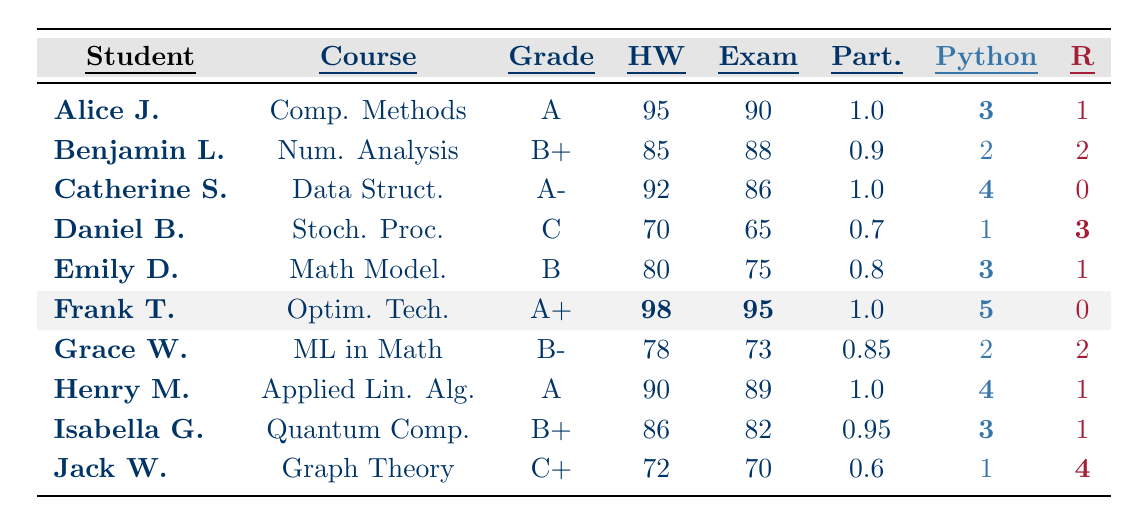What is the final grade of Henry Martinez? By looking at the table, I find the row corresponding to Henry Martinez, and the final grade listed under the "Grade" column is "A."
Answer: A How many homework points did Frank Thompson earn? In the row for Frank Thompson, the homework score located in the "HW" column shows 98 points.
Answer: 98 Which student had the highest exam score? I check the "Exam" column for each student and see that Frank Thompson has the highest score of 95.
Answer: Frank Thompson What is the average Participation score of all students? I sum up the participation scores (1.0 + 0.9 + 1.0 + 0.7 + 0.8 + 1.0 + 0.85 + 1.0 + 0.95 + 0.6) = 9.1 and divide by 10 (the number of students), resulting in an average of 0.91.
Answer: 0.91 Does any student have a higher number of Python projects than R projects? I examine each student's Python and R project counts and find that students such as Alice Johnson and Catherine Smith have more Python projects (3 and 4, respectively) compared to their R projects.
Answer: Yes What is the total number of Python projects completed by all students? I take the Python projects count for each student (3 + 2 + 4 + 1 + 3 + 5 + 2 + 4 + 3 + 1) = 24 to find the total.
Answer: 24 Which student has the lowest final grade? By reviewing the "Grade" column, I see that Daniel Brown has the lowest final grade of "C."
Answer: Daniel Brown How many students scored above a B grade? I analyze the "Grade" column and find that students with grades A, A-, and B+ are above a B. These include Alice Johnson, Catherine Smith, Frank Thompson, Henry Martinez, and Isabella Garcia, totaling 5 students.
Answer: 5 What is the difference between the highest and lowest Homework score? The highest Homework score is 98 (Frank Thompson) and the lowest is 70 (Daniel Brown). The difference is 98 - 70 = 28.
Answer: 28 How many students completed projects in both Python and R? I look through the table and find that Benjamin Lee, Daniel Brown, Grace White, and Jack Wilson all have non-zero counts for both Python and R projects, totaling 4 students.
Answer: 4 